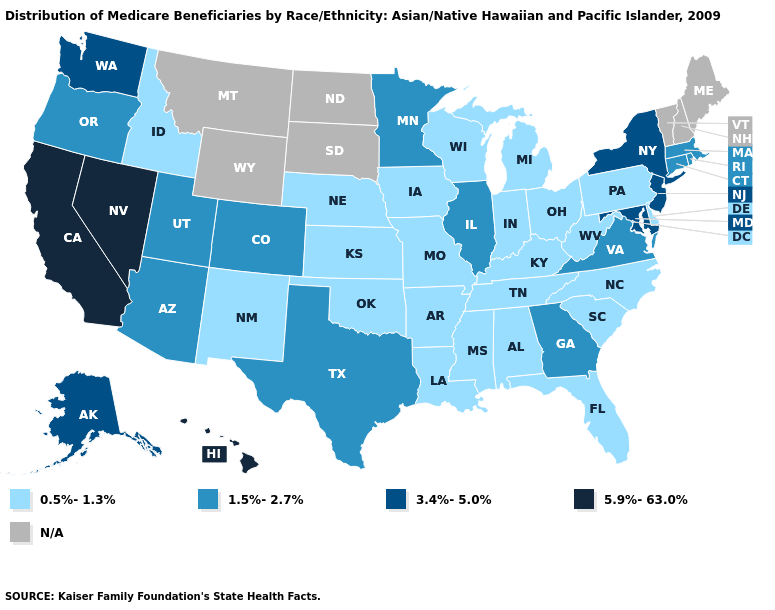Does the first symbol in the legend represent the smallest category?
Keep it brief. Yes. Does the map have missing data?
Concise answer only. Yes. What is the highest value in states that border Ohio?
Answer briefly. 0.5%-1.3%. Which states have the lowest value in the USA?
Be succinct. Alabama, Arkansas, Delaware, Florida, Idaho, Indiana, Iowa, Kansas, Kentucky, Louisiana, Michigan, Mississippi, Missouri, Nebraska, New Mexico, North Carolina, Ohio, Oklahoma, Pennsylvania, South Carolina, Tennessee, West Virginia, Wisconsin. Name the states that have a value in the range 1.5%-2.7%?
Answer briefly. Arizona, Colorado, Connecticut, Georgia, Illinois, Massachusetts, Minnesota, Oregon, Rhode Island, Texas, Utah, Virginia. What is the highest value in the Northeast ?
Short answer required. 3.4%-5.0%. Name the states that have a value in the range 5.9%-63.0%?
Give a very brief answer. California, Hawaii, Nevada. Does New Mexico have the lowest value in the USA?
Answer briefly. Yes. What is the highest value in the West ?
Write a very short answer. 5.9%-63.0%. What is the highest value in states that border Virginia?
Be succinct. 3.4%-5.0%. What is the highest value in the USA?
Be succinct. 5.9%-63.0%. What is the lowest value in the Northeast?
Short answer required. 0.5%-1.3%. Among the states that border Georgia , which have the highest value?
Short answer required. Alabama, Florida, North Carolina, South Carolina, Tennessee. What is the lowest value in the MidWest?
Quick response, please. 0.5%-1.3%. What is the value of Rhode Island?
Concise answer only. 1.5%-2.7%. 